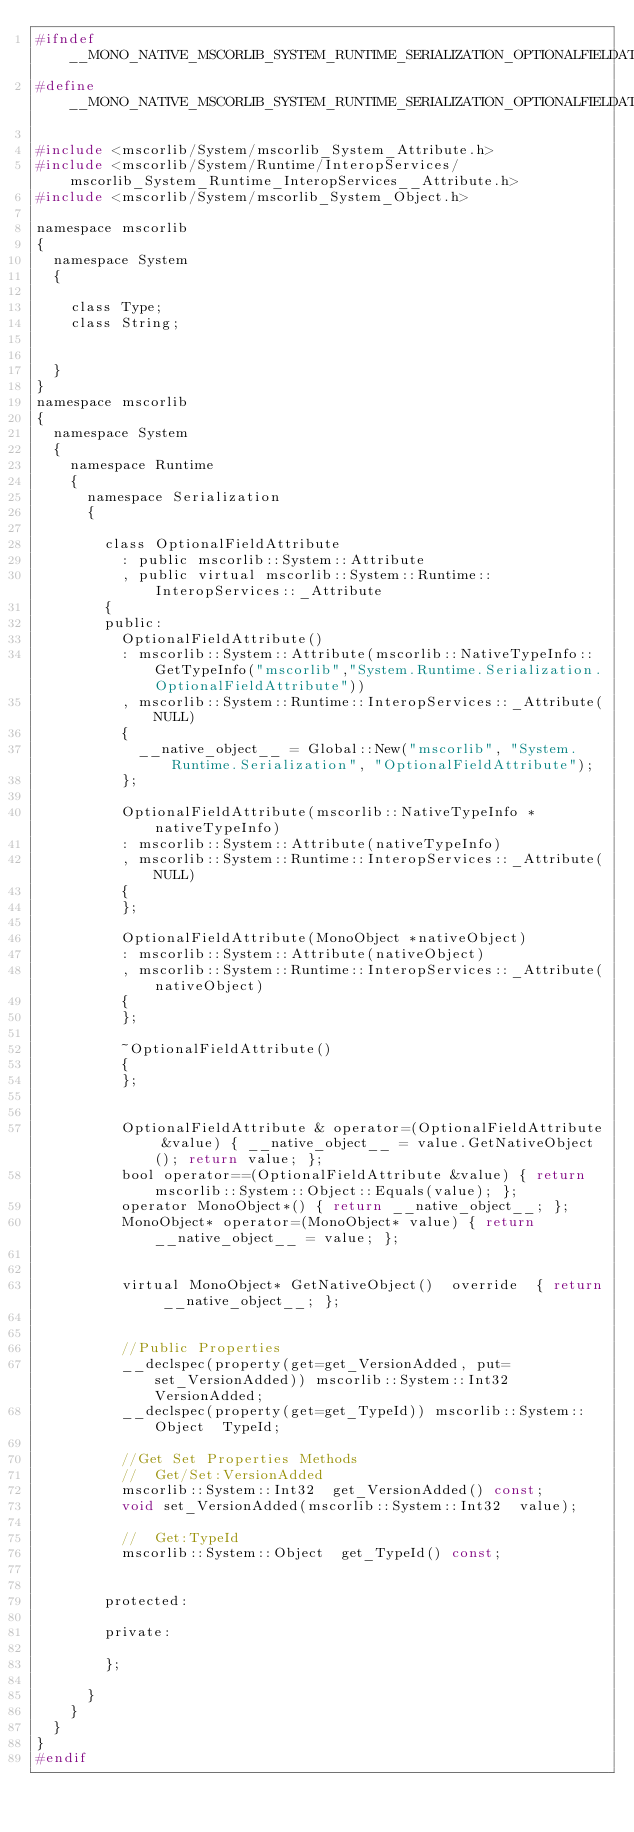Convert code to text. <code><loc_0><loc_0><loc_500><loc_500><_C_>#ifndef __MONO_NATIVE_MSCORLIB_SYSTEM_RUNTIME_SERIALIZATION_OPTIONALFIELDATTRIBUTE_H
#define __MONO_NATIVE_MSCORLIB_SYSTEM_RUNTIME_SERIALIZATION_OPTIONALFIELDATTRIBUTE_H

#include <mscorlib/System/mscorlib_System_Attribute.h>
#include <mscorlib/System/Runtime/InteropServices/mscorlib_System_Runtime_InteropServices__Attribute.h>
#include <mscorlib/System/mscorlib_System_Object.h>

namespace mscorlib
{
	namespace System
	{

		class Type;
		class String;
		

	}
}
namespace mscorlib
{
	namespace System
	{
		namespace Runtime
		{
			namespace Serialization
			{

				class OptionalFieldAttribute
					: public mscorlib::System::Attribute
					, public virtual mscorlib::System::Runtime::InteropServices::_Attribute
				{
				public:
					OptionalFieldAttribute()
					: mscorlib::System::Attribute(mscorlib::NativeTypeInfo::GetTypeInfo("mscorlib","System.Runtime.Serialization.OptionalFieldAttribute"))
					, mscorlib::System::Runtime::InteropServices::_Attribute(NULL)
					{
						__native_object__ = Global::New("mscorlib", "System.Runtime.Serialization", "OptionalFieldAttribute");
					};
				
					OptionalFieldAttribute(mscorlib::NativeTypeInfo *nativeTypeInfo)
					: mscorlib::System::Attribute(nativeTypeInfo)
					, mscorlib::System::Runtime::InteropServices::_Attribute(NULL)
					{
					};
				
					OptionalFieldAttribute(MonoObject *nativeObject)
					: mscorlib::System::Attribute(nativeObject)
					, mscorlib::System::Runtime::InteropServices::_Attribute(nativeObject)
					{
					};
				
					~OptionalFieldAttribute()
					{
					};
				

					OptionalFieldAttribute & operator=(OptionalFieldAttribute &value) { __native_object__ = value.GetNativeObject(); return value; };
					bool operator==(OptionalFieldAttribute &value) { return mscorlib::System::Object::Equals(value); };
					operator MonoObject*() { return __native_object__; };
					MonoObject* operator=(MonoObject* value) { return __native_object__ = value; };


					virtual MonoObject* GetNativeObject()  override  { return __native_object__; };


					//Public Properties
					__declspec(property(get=get_VersionAdded, put=set_VersionAdded)) mscorlib::System::Int32  VersionAdded;
					__declspec(property(get=get_TypeId)) mscorlib::System::Object  TypeId;

					//Get Set Properties Methods
					//	Get/Set:VersionAdded
					mscorlib::System::Int32  get_VersionAdded() const;
					void set_VersionAdded(mscorlib::System::Int32  value);

					//	Get:TypeId
					mscorlib::System::Object  get_TypeId() const;

				
				protected:
				
				private:
				
				};

			}
		}
	}
}
#endif
</code> 